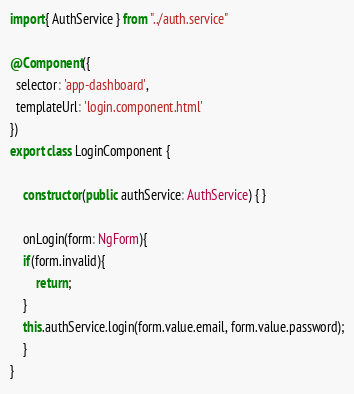Convert code to text. <code><loc_0><loc_0><loc_500><loc_500><_TypeScript_>import{ AuthService } from "../auth.service"

@Component({
  selector: 'app-dashboard',
  templateUrl: 'login.component.html'
})
export class LoginComponent { 

	constructor(public authService: AuthService) { }

	onLogin(form: NgForm){
	if(form.invalid){
		return;
	}
	this.authService.login(form.value.email, form.value.password);
	}
}
</code> 